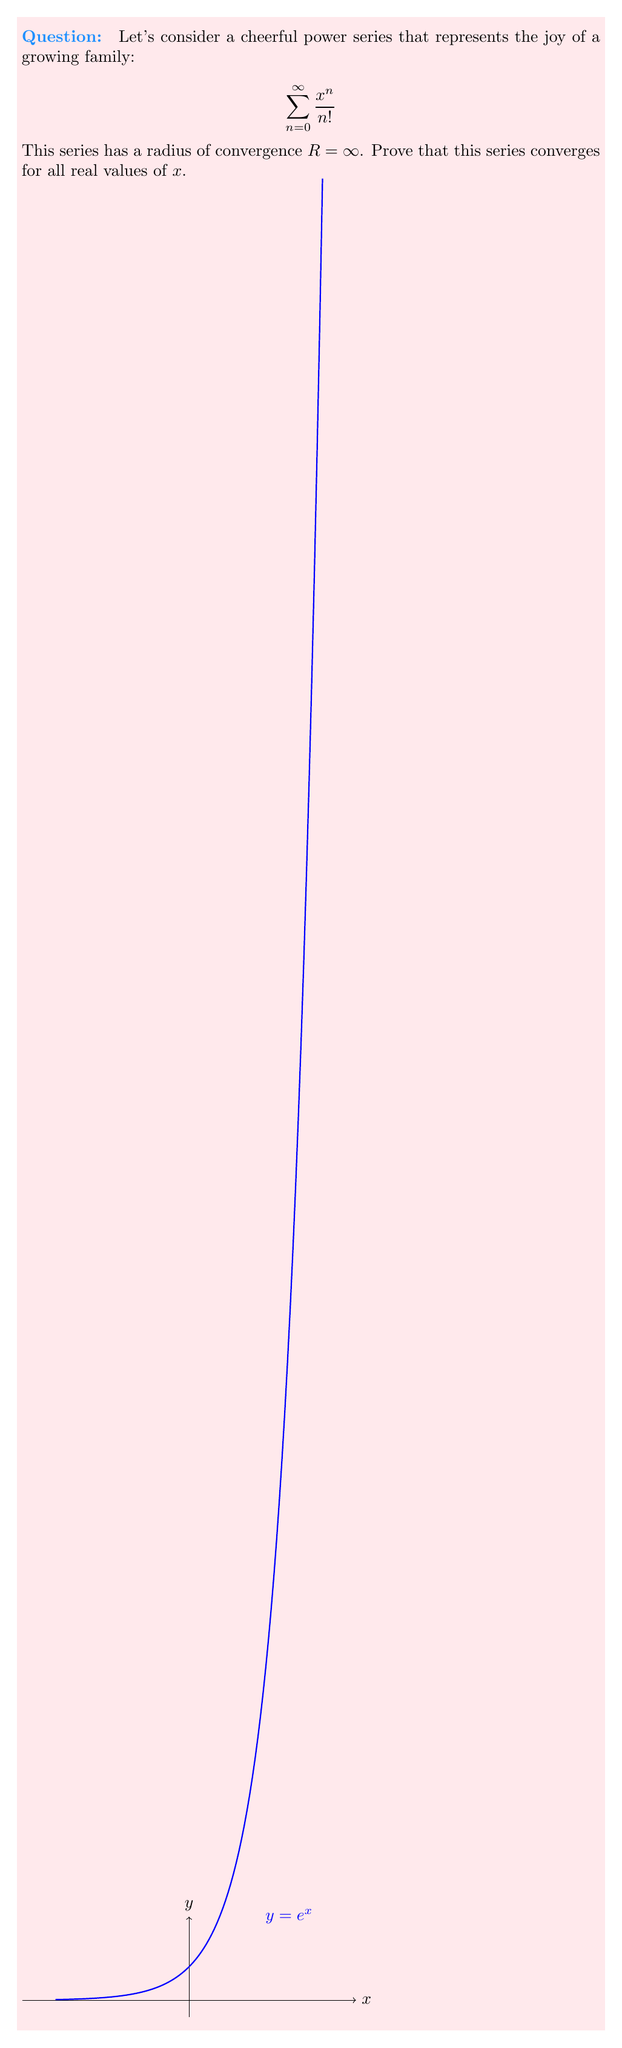Provide a solution to this math problem. Let's prove the convergence of this cheerful series step by step:

1) First, we'll use the ratio test to find the radius of convergence:

   $$\lim_{n \to \infty} \left|\frac{a_{n+1}}{a_n}\right| = \lim_{n \to \infty} \left|\frac{\frac{x^{n+1}}{(n+1)!}}{\frac{x^n}{n!}}\right| = \lim_{n \to \infty} \left|\frac{x}{n+1}\right| = 0$$

   This limit is 0 for any finite $x$, so the radius of convergence is indeed $R = \infty$.

2) Now, to prove convergence for all real $x$, we'll use the comparison test with a known convergent series.

3) For any real $x$, we can find a positive integer $M$ such that $|x| < M$.

4) Then, for $n > M$:

   $$\left|\frac{x^n}{n!}\right| < \frac{M^n}{n!}$$

5) The series $\sum_{n=0}^{\infty} \frac{M^n}{n!}$ is known to converge for any positive real $M$ (it's the Taylor series for $e^M$).

6) By the comparison test, since $\left|\frac{x^n}{n!}\right| < \frac{M^n}{n!}$ for all $n > M$, and $\sum_{n=0}^{\infty} \frac{M^n}{n!}$ converges, our original series $\sum_{n=0}^{\infty} \frac{x^n}{n!}$ must also converge.

7) This proves that the series converges for all real values of $x$.

(Note: This cheerful series actually represents $e^x$, which is always positive, making it a perfect representation of joy and growth!)
Answer: The series converges for all real $x$ by the comparison test with $\sum_{n=0}^{\infty} \frac{M^n}{n!}$ for $|x| < M$. 